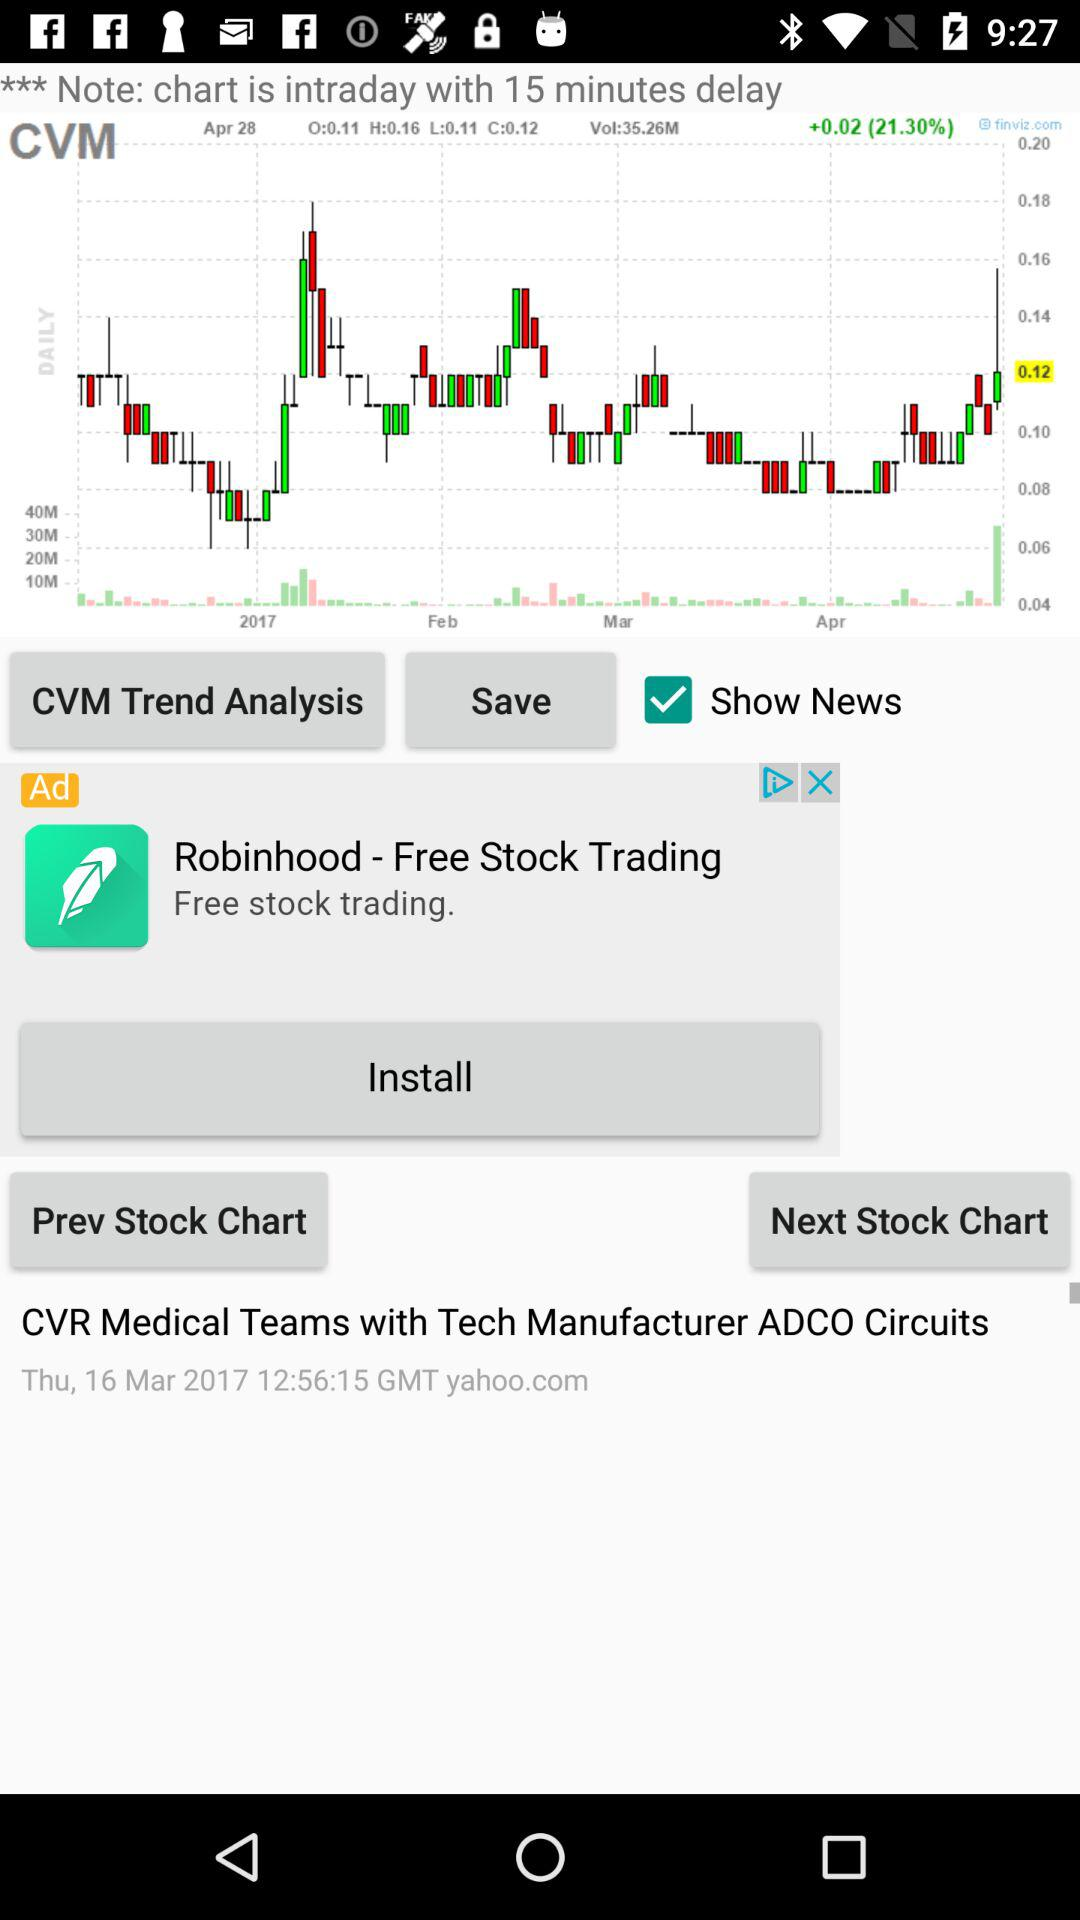How many minutes is the intraday chart delayed? The intraday chart is delayed by 15 minutes. 